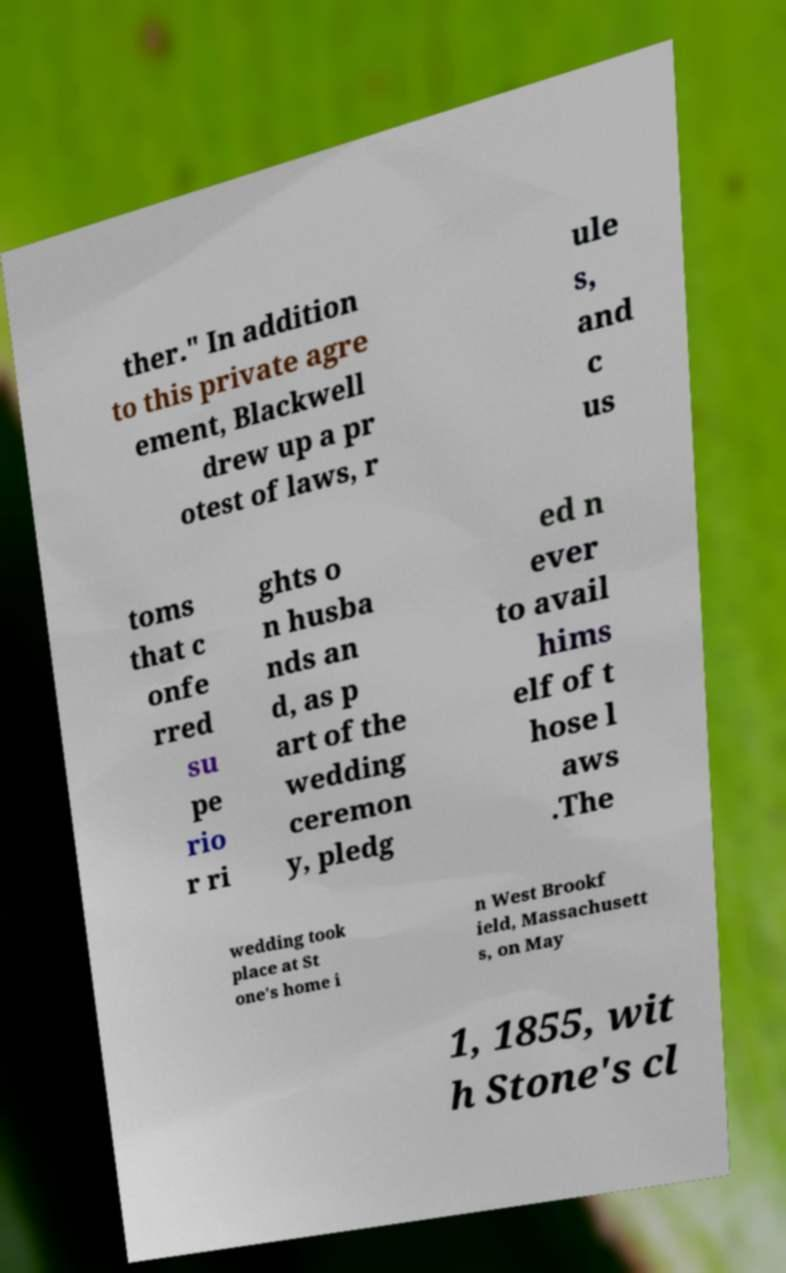What messages or text are displayed in this image? I need them in a readable, typed format. ther." In addition to this private agre ement, Blackwell drew up a pr otest of laws, r ule s, and c us toms that c onfe rred su pe rio r ri ghts o n husba nds an d, as p art of the wedding ceremon y, pledg ed n ever to avail hims elf of t hose l aws .The wedding took place at St one's home i n West Brookf ield, Massachusett s, on May 1, 1855, wit h Stone's cl 